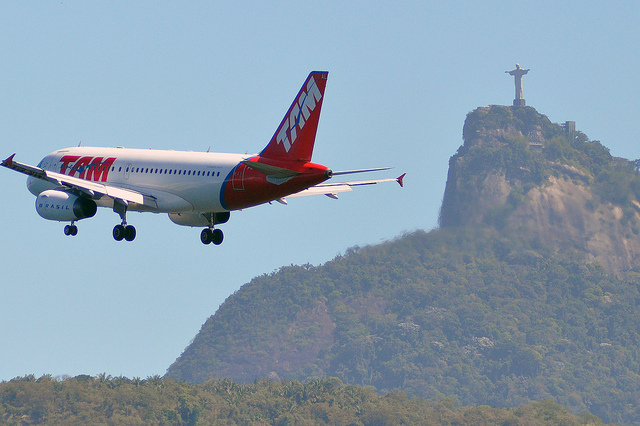Can you describe the background behind the statue? Certainly. Behind the Christ the Redeemer statue, the background includes a clear sky and an array of other hills or mountains extending into the distance, contributing to a scenic and picturesque setting. 